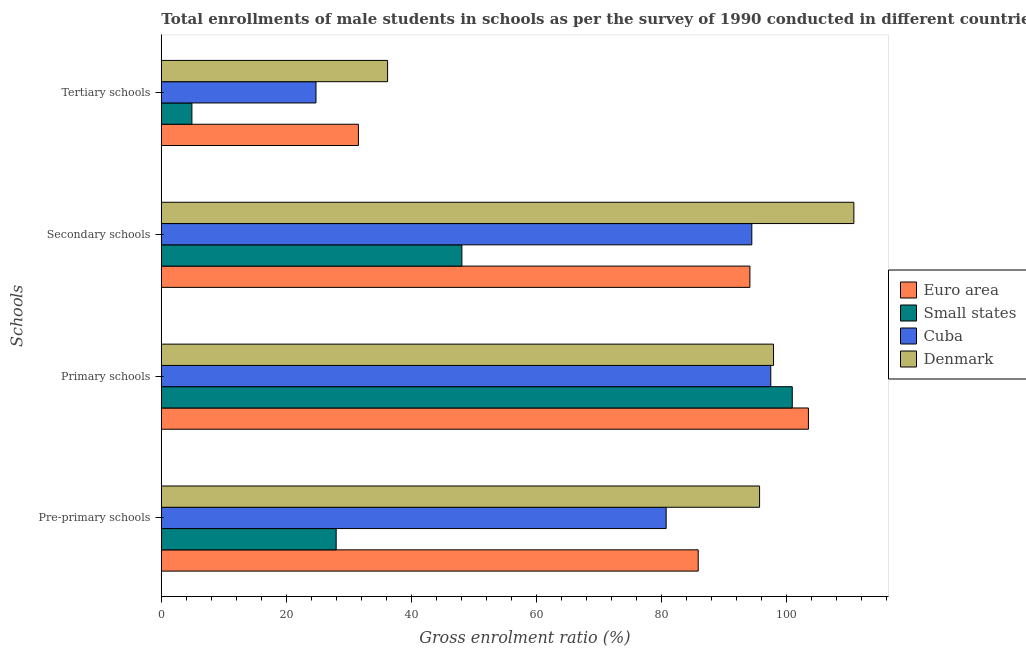How many different coloured bars are there?
Offer a terse response. 4. How many groups of bars are there?
Offer a terse response. 4. Are the number of bars per tick equal to the number of legend labels?
Your response must be concise. Yes. Are the number of bars on each tick of the Y-axis equal?
Offer a very short reply. Yes. How many bars are there on the 2nd tick from the top?
Your answer should be compact. 4. What is the label of the 1st group of bars from the top?
Offer a terse response. Tertiary schools. What is the gross enrolment ratio(male) in tertiary schools in Euro area?
Ensure brevity in your answer.  31.51. Across all countries, what is the maximum gross enrolment ratio(male) in pre-primary schools?
Offer a very short reply. 95.66. Across all countries, what is the minimum gross enrolment ratio(male) in secondary schools?
Ensure brevity in your answer.  48.06. In which country was the gross enrolment ratio(male) in primary schools maximum?
Your answer should be very brief. Euro area. In which country was the gross enrolment ratio(male) in secondary schools minimum?
Your answer should be very brief. Small states. What is the total gross enrolment ratio(male) in tertiary schools in the graph?
Offer a terse response. 97.32. What is the difference between the gross enrolment ratio(male) in secondary schools in Small states and that in Euro area?
Your response must be concise. -46.05. What is the difference between the gross enrolment ratio(male) in secondary schools in Cuba and the gross enrolment ratio(male) in pre-primary schools in Denmark?
Offer a terse response. -1.24. What is the average gross enrolment ratio(male) in pre-primary schools per country?
Make the answer very short. 72.55. What is the difference between the gross enrolment ratio(male) in primary schools and gross enrolment ratio(male) in secondary schools in Euro area?
Make the answer very short. 9.35. In how many countries, is the gross enrolment ratio(male) in secondary schools greater than 32 %?
Give a very brief answer. 4. What is the ratio of the gross enrolment ratio(male) in secondary schools in Euro area to that in Cuba?
Your response must be concise. 1. Is the gross enrolment ratio(male) in secondary schools in Denmark less than that in Small states?
Offer a terse response. No. What is the difference between the highest and the second highest gross enrolment ratio(male) in pre-primary schools?
Offer a very short reply. 9.81. What is the difference between the highest and the lowest gross enrolment ratio(male) in primary schools?
Ensure brevity in your answer.  6.02. In how many countries, is the gross enrolment ratio(male) in secondary schools greater than the average gross enrolment ratio(male) in secondary schools taken over all countries?
Your answer should be very brief. 3. What does the 1st bar from the top in Primary schools represents?
Give a very brief answer. Denmark. What does the 3rd bar from the bottom in Tertiary schools represents?
Your response must be concise. Cuba. Are all the bars in the graph horizontal?
Provide a succinct answer. Yes. How many countries are there in the graph?
Give a very brief answer. 4. What is the difference between two consecutive major ticks on the X-axis?
Provide a short and direct response. 20. Are the values on the major ticks of X-axis written in scientific E-notation?
Provide a short and direct response. No. Where does the legend appear in the graph?
Provide a short and direct response. Center right. What is the title of the graph?
Keep it short and to the point. Total enrollments of male students in schools as per the survey of 1990 conducted in different countries. Does "Nepal" appear as one of the legend labels in the graph?
Keep it short and to the point. No. What is the label or title of the X-axis?
Keep it short and to the point. Gross enrolment ratio (%). What is the label or title of the Y-axis?
Your answer should be compact. Schools. What is the Gross enrolment ratio (%) in Euro area in Pre-primary schools?
Keep it short and to the point. 85.85. What is the Gross enrolment ratio (%) in Small states in Pre-primary schools?
Provide a short and direct response. 27.96. What is the Gross enrolment ratio (%) in Cuba in Pre-primary schools?
Ensure brevity in your answer.  80.72. What is the Gross enrolment ratio (%) of Denmark in Pre-primary schools?
Give a very brief answer. 95.66. What is the Gross enrolment ratio (%) of Euro area in Primary schools?
Your answer should be very brief. 103.47. What is the Gross enrolment ratio (%) in Small states in Primary schools?
Offer a terse response. 100.89. What is the Gross enrolment ratio (%) in Cuba in Primary schools?
Keep it short and to the point. 97.45. What is the Gross enrolment ratio (%) in Denmark in Primary schools?
Offer a very short reply. 97.89. What is the Gross enrolment ratio (%) in Euro area in Secondary schools?
Your response must be concise. 94.11. What is the Gross enrolment ratio (%) of Small states in Secondary schools?
Make the answer very short. 48.06. What is the Gross enrolment ratio (%) in Cuba in Secondary schools?
Provide a short and direct response. 94.42. What is the Gross enrolment ratio (%) of Denmark in Secondary schools?
Provide a short and direct response. 110.74. What is the Gross enrolment ratio (%) of Euro area in Tertiary schools?
Offer a very short reply. 31.51. What is the Gross enrolment ratio (%) of Small states in Tertiary schools?
Ensure brevity in your answer.  4.89. What is the Gross enrolment ratio (%) of Cuba in Tertiary schools?
Offer a very short reply. 24.73. What is the Gross enrolment ratio (%) of Denmark in Tertiary schools?
Ensure brevity in your answer.  36.18. Across all Schools, what is the maximum Gross enrolment ratio (%) in Euro area?
Provide a short and direct response. 103.47. Across all Schools, what is the maximum Gross enrolment ratio (%) in Small states?
Keep it short and to the point. 100.89. Across all Schools, what is the maximum Gross enrolment ratio (%) in Cuba?
Make the answer very short. 97.45. Across all Schools, what is the maximum Gross enrolment ratio (%) of Denmark?
Make the answer very short. 110.74. Across all Schools, what is the minimum Gross enrolment ratio (%) of Euro area?
Offer a terse response. 31.51. Across all Schools, what is the minimum Gross enrolment ratio (%) of Small states?
Your answer should be very brief. 4.89. Across all Schools, what is the minimum Gross enrolment ratio (%) of Cuba?
Offer a terse response. 24.73. Across all Schools, what is the minimum Gross enrolment ratio (%) in Denmark?
Your answer should be compact. 36.18. What is the total Gross enrolment ratio (%) in Euro area in the graph?
Provide a succinct answer. 314.94. What is the total Gross enrolment ratio (%) of Small states in the graph?
Provide a short and direct response. 181.8. What is the total Gross enrolment ratio (%) of Cuba in the graph?
Your response must be concise. 297.32. What is the total Gross enrolment ratio (%) of Denmark in the graph?
Provide a succinct answer. 340.47. What is the difference between the Gross enrolment ratio (%) of Euro area in Pre-primary schools and that in Primary schools?
Provide a succinct answer. -17.62. What is the difference between the Gross enrolment ratio (%) in Small states in Pre-primary schools and that in Primary schools?
Provide a succinct answer. -72.93. What is the difference between the Gross enrolment ratio (%) in Cuba in Pre-primary schools and that in Primary schools?
Provide a succinct answer. -16.73. What is the difference between the Gross enrolment ratio (%) of Denmark in Pre-primary schools and that in Primary schools?
Ensure brevity in your answer.  -2.23. What is the difference between the Gross enrolment ratio (%) in Euro area in Pre-primary schools and that in Secondary schools?
Give a very brief answer. -8.27. What is the difference between the Gross enrolment ratio (%) of Small states in Pre-primary schools and that in Secondary schools?
Your answer should be compact. -20.1. What is the difference between the Gross enrolment ratio (%) of Cuba in Pre-primary schools and that in Secondary schools?
Make the answer very short. -13.7. What is the difference between the Gross enrolment ratio (%) in Denmark in Pre-primary schools and that in Secondary schools?
Offer a terse response. -15.08. What is the difference between the Gross enrolment ratio (%) in Euro area in Pre-primary schools and that in Tertiary schools?
Make the answer very short. 54.33. What is the difference between the Gross enrolment ratio (%) of Small states in Pre-primary schools and that in Tertiary schools?
Offer a terse response. 23.07. What is the difference between the Gross enrolment ratio (%) of Cuba in Pre-primary schools and that in Tertiary schools?
Ensure brevity in your answer.  55.99. What is the difference between the Gross enrolment ratio (%) of Denmark in Pre-primary schools and that in Tertiary schools?
Your answer should be compact. 59.48. What is the difference between the Gross enrolment ratio (%) in Euro area in Primary schools and that in Secondary schools?
Your response must be concise. 9.35. What is the difference between the Gross enrolment ratio (%) in Small states in Primary schools and that in Secondary schools?
Make the answer very short. 52.83. What is the difference between the Gross enrolment ratio (%) of Cuba in Primary schools and that in Secondary schools?
Make the answer very short. 3.03. What is the difference between the Gross enrolment ratio (%) in Denmark in Primary schools and that in Secondary schools?
Your answer should be very brief. -12.84. What is the difference between the Gross enrolment ratio (%) in Euro area in Primary schools and that in Tertiary schools?
Offer a very short reply. 71.96. What is the difference between the Gross enrolment ratio (%) in Small states in Primary schools and that in Tertiary schools?
Ensure brevity in your answer.  95.99. What is the difference between the Gross enrolment ratio (%) in Cuba in Primary schools and that in Tertiary schools?
Offer a very short reply. 72.72. What is the difference between the Gross enrolment ratio (%) in Denmark in Primary schools and that in Tertiary schools?
Your answer should be compact. 61.71. What is the difference between the Gross enrolment ratio (%) of Euro area in Secondary schools and that in Tertiary schools?
Provide a short and direct response. 62.6. What is the difference between the Gross enrolment ratio (%) in Small states in Secondary schools and that in Tertiary schools?
Your answer should be very brief. 43.17. What is the difference between the Gross enrolment ratio (%) of Cuba in Secondary schools and that in Tertiary schools?
Offer a very short reply. 69.69. What is the difference between the Gross enrolment ratio (%) of Denmark in Secondary schools and that in Tertiary schools?
Keep it short and to the point. 74.55. What is the difference between the Gross enrolment ratio (%) of Euro area in Pre-primary schools and the Gross enrolment ratio (%) of Small states in Primary schools?
Provide a succinct answer. -15.04. What is the difference between the Gross enrolment ratio (%) of Euro area in Pre-primary schools and the Gross enrolment ratio (%) of Cuba in Primary schools?
Keep it short and to the point. -11.6. What is the difference between the Gross enrolment ratio (%) in Euro area in Pre-primary schools and the Gross enrolment ratio (%) in Denmark in Primary schools?
Provide a succinct answer. -12.04. What is the difference between the Gross enrolment ratio (%) in Small states in Pre-primary schools and the Gross enrolment ratio (%) in Cuba in Primary schools?
Your answer should be compact. -69.49. What is the difference between the Gross enrolment ratio (%) in Small states in Pre-primary schools and the Gross enrolment ratio (%) in Denmark in Primary schools?
Your response must be concise. -69.93. What is the difference between the Gross enrolment ratio (%) in Cuba in Pre-primary schools and the Gross enrolment ratio (%) in Denmark in Primary schools?
Ensure brevity in your answer.  -17.17. What is the difference between the Gross enrolment ratio (%) of Euro area in Pre-primary schools and the Gross enrolment ratio (%) of Small states in Secondary schools?
Your response must be concise. 37.79. What is the difference between the Gross enrolment ratio (%) of Euro area in Pre-primary schools and the Gross enrolment ratio (%) of Cuba in Secondary schools?
Provide a succinct answer. -8.57. What is the difference between the Gross enrolment ratio (%) of Euro area in Pre-primary schools and the Gross enrolment ratio (%) of Denmark in Secondary schools?
Make the answer very short. -24.89. What is the difference between the Gross enrolment ratio (%) in Small states in Pre-primary schools and the Gross enrolment ratio (%) in Cuba in Secondary schools?
Your answer should be very brief. -66.46. What is the difference between the Gross enrolment ratio (%) in Small states in Pre-primary schools and the Gross enrolment ratio (%) in Denmark in Secondary schools?
Offer a very short reply. -82.78. What is the difference between the Gross enrolment ratio (%) of Cuba in Pre-primary schools and the Gross enrolment ratio (%) of Denmark in Secondary schools?
Offer a terse response. -30.01. What is the difference between the Gross enrolment ratio (%) in Euro area in Pre-primary schools and the Gross enrolment ratio (%) in Small states in Tertiary schools?
Your answer should be very brief. 80.95. What is the difference between the Gross enrolment ratio (%) in Euro area in Pre-primary schools and the Gross enrolment ratio (%) in Cuba in Tertiary schools?
Ensure brevity in your answer.  61.12. What is the difference between the Gross enrolment ratio (%) in Euro area in Pre-primary schools and the Gross enrolment ratio (%) in Denmark in Tertiary schools?
Your response must be concise. 49.66. What is the difference between the Gross enrolment ratio (%) of Small states in Pre-primary schools and the Gross enrolment ratio (%) of Cuba in Tertiary schools?
Provide a short and direct response. 3.23. What is the difference between the Gross enrolment ratio (%) in Small states in Pre-primary schools and the Gross enrolment ratio (%) in Denmark in Tertiary schools?
Provide a succinct answer. -8.22. What is the difference between the Gross enrolment ratio (%) in Cuba in Pre-primary schools and the Gross enrolment ratio (%) in Denmark in Tertiary schools?
Provide a succinct answer. 44.54. What is the difference between the Gross enrolment ratio (%) in Euro area in Primary schools and the Gross enrolment ratio (%) in Small states in Secondary schools?
Your answer should be compact. 55.41. What is the difference between the Gross enrolment ratio (%) in Euro area in Primary schools and the Gross enrolment ratio (%) in Cuba in Secondary schools?
Make the answer very short. 9.05. What is the difference between the Gross enrolment ratio (%) of Euro area in Primary schools and the Gross enrolment ratio (%) of Denmark in Secondary schools?
Give a very brief answer. -7.27. What is the difference between the Gross enrolment ratio (%) of Small states in Primary schools and the Gross enrolment ratio (%) of Cuba in Secondary schools?
Provide a succinct answer. 6.47. What is the difference between the Gross enrolment ratio (%) of Small states in Primary schools and the Gross enrolment ratio (%) of Denmark in Secondary schools?
Provide a short and direct response. -9.85. What is the difference between the Gross enrolment ratio (%) of Cuba in Primary schools and the Gross enrolment ratio (%) of Denmark in Secondary schools?
Ensure brevity in your answer.  -13.29. What is the difference between the Gross enrolment ratio (%) of Euro area in Primary schools and the Gross enrolment ratio (%) of Small states in Tertiary schools?
Your answer should be compact. 98.58. What is the difference between the Gross enrolment ratio (%) in Euro area in Primary schools and the Gross enrolment ratio (%) in Cuba in Tertiary schools?
Give a very brief answer. 78.74. What is the difference between the Gross enrolment ratio (%) in Euro area in Primary schools and the Gross enrolment ratio (%) in Denmark in Tertiary schools?
Provide a succinct answer. 67.29. What is the difference between the Gross enrolment ratio (%) of Small states in Primary schools and the Gross enrolment ratio (%) of Cuba in Tertiary schools?
Offer a terse response. 76.16. What is the difference between the Gross enrolment ratio (%) of Small states in Primary schools and the Gross enrolment ratio (%) of Denmark in Tertiary schools?
Provide a short and direct response. 64.7. What is the difference between the Gross enrolment ratio (%) in Cuba in Primary schools and the Gross enrolment ratio (%) in Denmark in Tertiary schools?
Provide a succinct answer. 61.27. What is the difference between the Gross enrolment ratio (%) of Euro area in Secondary schools and the Gross enrolment ratio (%) of Small states in Tertiary schools?
Ensure brevity in your answer.  89.22. What is the difference between the Gross enrolment ratio (%) in Euro area in Secondary schools and the Gross enrolment ratio (%) in Cuba in Tertiary schools?
Your answer should be compact. 69.38. What is the difference between the Gross enrolment ratio (%) in Euro area in Secondary schools and the Gross enrolment ratio (%) in Denmark in Tertiary schools?
Provide a short and direct response. 57.93. What is the difference between the Gross enrolment ratio (%) of Small states in Secondary schools and the Gross enrolment ratio (%) of Cuba in Tertiary schools?
Provide a succinct answer. 23.33. What is the difference between the Gross enrolment ratio (%) in Small states in Secondary schools and the Gross enrolment ratio (%) in Denmark in Tertiary schools?
Give a very brief answer. 11.88. What is the difference between the Gross enrolment ratio (%) in Cuba in Secondary schools and the Gross enrolment ratio (%) in Denmark in Tertiary schools?
Ensure brevity in your answer.  58.23. What is the average Gross enrolment ratio (%) in Euro area per Schools?
Make the answer very short. 78.74. What is the average Gross enrolment ratio (%) of Small states per Schools?
Offer a terse response. 45.45. What is the average Gross enrolment ratio (%) of Cuba per Schools?
Your response must be concise. 74.33. What is the average Gross enrolment ratio (%) in Denmark per Schools?
Your response must be concise. 85.12. What is the difference between the Gross enrolment ratio (%) of Euro area and Gross enrolment ratio (%) of Small states in Pre-primary schools?
Provide a succinct answer. 57.89. What is the difference between the Gross enrolment ratio (%) in Euro area and Gross enrolment ratio (%) in Cuba in Pre-primary schools?
Make the answer very short. 5.13. What is the difference between the Gross enrolment ratio (%) of Euro area and Gross enrolment ratio (%) of Denmark in Pre-primary schools?
Offer a very short reply. -9.81. What is the difference between the Gross enrolment ratio (%) of Small states and Gross enrolment ratio (%) of Cuba in Pre-primary schools?
Ensure brevity in your answer.  -52.76. What is the difference between the Gross enrolment ratio (%) in Small states and Gross enrolment ratio (%) in Denmark in Pre-primary schools?
Provide a succinct answer. -67.7. What is the difference between the Gross enrolment ratio (%) of Cuba and Gross enrolment ratio (%) of Denmark in Pre-primary schools?
Your response must be concise. -14.94. What is the difference between the Gross enrolment ratio (%) in Euro area and Gross enrolment ratio (%) in Small states in Primary schools?
Provide a succinct answer. 2.58. What is the difference between the Gross enrolment ratio (%) of Euro area and Gross enrolment ratio (%) of Cuba in Primary schools?
Offer a terse response. 6.02. What is the difference between the Gross enrolment ratio (%) in Euro area and Gross enrolment ratio (%) in Denmark in Primary schools?
Provide a short and direct response. 5.58. What is the difference between the Gross enrolment ratio (%) in Small states and Gross enrolment ratio (%) in Cuba in Primary schools?
Your response must be concise. 3.44. What is the difference between the Gross enrolment ratio (%) of Small states and Gross enrolment ratio (%) of Denmark in Primary schools?
Make the answer very short. 3. What is the difference between the Gross enrolment ratio (%) of Cuba and Gross enrolment ratio (%) of Denmark in Primary schools?
Keep it short and to the point. -0.44. What is the difference between the Gross enrolment ratio (%) in Euro area and Gross enrolment ratio (%) in Small states in Secondary schools?
Ensure brevity in your answer.  46.05. What is the difference between the Gross enrolment ratio (%) in Euro area and Gross enrolment ratio (%) in Cuba in Secondary schools?
Offer a terse response. -0.3. What is the difference between the Gross enrolment ratio (%) in Euro area and Gross enrolment ratio (%) in Denmark in Secondary schools?
Offer a very short reply. -16.62. What is the difference between the Gross enrolment ratio (%) in Small states and Gross enrolment ratio (%) in Cuba in Secondary schools?
Make the answer very short. -46.36. What is the difference between the Gross enrolment ratio (%) in Small states and Gross enrolment ratio (%) in Denmark in Secondary schools?
Your response must be concise. -62.68. What is the difference between the Gross enrolment ratio (%) of Cuba and Gross enrolment ratio (%) of Denmark in Secondary schools?
Offer a terse response. -16.32. What is the difference between the Gross enrolment ratio (%) in Euro area and Gross enrolment ratio (%) in Small states in Tertiary schools?
Provide a succinct answer. 26.62. What is the difference between the Gross enrolment ratio (%) in Euro area and Gross enrolment ratio (%) in Cuba in Tertiary schools?
Your response must be concise. 6.78. What is the difference between the Gross enrolment ratio (%) of Euro area and Gross enrolment ratio (%) of Denmark in Tertiary schools?
Keep it short and to the point. -4.67. What is the difference between the Gross enrolment ratio (%) of Small states and Gross enrolment ratio (%) of Cuba in Tertiary schools?
Your answer should be compact. -19.84. What is the difference between the Gross enrolment ratio (%) in Small states and Gross enrolment ratio (%) in Denmark in Tertiary schools?
Keep it short and to the point. -31.29. What is the difference between the Gross enrolment ratio (%) in Cuba and Gross enrolment ratio (%) in Denmark in Tertiary schools?
Provide a short and direct response. -11.45. What is the ratio of the Gross enrolment ratio (%) of Euro area in Pre-primary schools to that in Primary schools?
Offer a terse response. 0.83. What is the ratio of the Gross enrolment ratio (%) of Small states in Pre-primary schools to that in Primary schools?
Ensure brevity in your answer.  0.28. What is the ratio of the Gross enrolment ratio (%) in Cuba in Pre-primary schools to that in Primary schools?
Provide a succinct answer. 0.83. What is the ratio of the Gross enrolment ratio (%) in Denmark in Pre-primary schools to that in Primary schools?
Provide a succinct answer. 0.98. What is the ratio of the Gross enrolment ratio (%) of Euro area in Pre-primary schools to that in Secondary schools?
Provide a short and direct response. 0.91. What is the ratio of the Gross enrolment ratio (%) of Small states in Pre-primary schools to that in Secondary schools?
Your response must be concise. 0.58. What is the ratio of the Gross enrolment ratio (%) in Cuba in Pre-primary schools to that in Secondary schools?
Keep it short and to the point. 0.85. What is the ratio of the Gross enrolment ratio (%) of Denmark in Pre-primary schools to that in Secondary schools?
Ensure brevity in your answer.  0.86. What is the ratio of the Gross enrolment ratio (%) of Euro area in Pre-primary schools to that in Tertiary schools?
Make the answer very short. 2.72. What is the ratio of the Gross enrolment ratio (%) of Small states in Pre-primary schools to that in Tertiary schools?
Offer a very short reply. 5.72. What is the ratio of the Gross enrolment ratio (%) in Cuba in Pre-primary schools to that in Tertiary schools?
Make the answer very short. 3.26. What is the ratio of the Gross enrolment ratio (%) in Denmark in Pre-primary schools to that in Tertiary schools?
Keep it short and to the point. 2.64. What is the ratio of the Gross enrolment ratio (%) in Euro area in Primary schools to that in Secondary schools?
Ensure brevity in your answer.  1.1. What is the ratio of the Gross enrolment ratio (%) of Small states in Primary schools to that in Secondary schools?
Your answer should be compact. 2.1. What is the ratio of the Gross enrolment ratio (%) of Cuba in Primary schools to that in Secondary schools?
Make the answer very short. 1.03. What is the ratio of the Gross enrolment ratio (%) of Denmark in Primary schools to that in Secondary schools?
Your answer should be very brief. 0.88. What is the ratio of the Gross enrolment ratio (%) in Euro area in Primary schools to that in Tertiary schools?
Give a very brief answer. 3.28. What is the ratio of the Gross enrolment ratio (%) in Small states in Primary schools to that in Tertiary schools?
Provide a short and direct response. 20.62. What is the ratio of the Gross enrolment ratio (%) of Cuba in Primary schools to that in Tertiary schools?
Keep it short and to the point. 3.94. What is the ratio of the Gross enrolment ratio (%) in Denmark in Primary schools to that in Tertiary schools?
Give a very brief answer. 2.71. What is the ratio of the Gross enrolment ratio (%) in Euro area in Secondary schools to that in Tertiary schools?
Your answer should be compact. 2.99. What is the ratio of the Gross enrolment ratio (%) in Small states in Secondary schools to that in Tertiary schools?
Your answer should be compact. 9.82. What is the ratio of the Gross enrolment ratio (%) of Cuba in Secondary schools to that in Tertiary schools?
Offer a very short reply. 3.82. What is the ratio of the Gross enrolment ratio (%) of Denmark in Secondary schools to that in Tertiary schools?
Provide a short and direct response. 3.06. What is the difference between the highest and the second highest Gross enrolment ratio (%) in Euro area?
Offer a terse response. 9.35. What is the difference between the highest and the second highest Gross enrolment ratio (%) of Small states?
Provide a succinct answer. 52.83. What is the difference between the highest and the second highest Gross enrolment ratio (%) of Cuba?
Your response must be concise. 3.03. What is the difference between the highest and the second highest Gross enrolment ratio (%) of Denmark?
Provide a short and direct response. 12.84. What is the difference between the highest and the lowest Gross enrolment ratio (%) of Euro area?
Your answer should be very brief. 71.96. What is the difference between the highest and the lowest Gross enrolment ratio (%) of Small states?
Keep it short and to the point. 95.99. What is the difference between the highest and the lowest Gross enrolment ratio (%) in Cuba?
Provide a short and direct response. 72.72. What is the difference between the highest and the lowest Gross enrolment ratio (%) in Denmark?
Give a very brief answer. 74.55. 